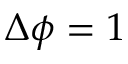Convert formula to latex. <formula><loc_0><loc_0><loc_500><loc_500>\Delta \phi = 1</formula> 